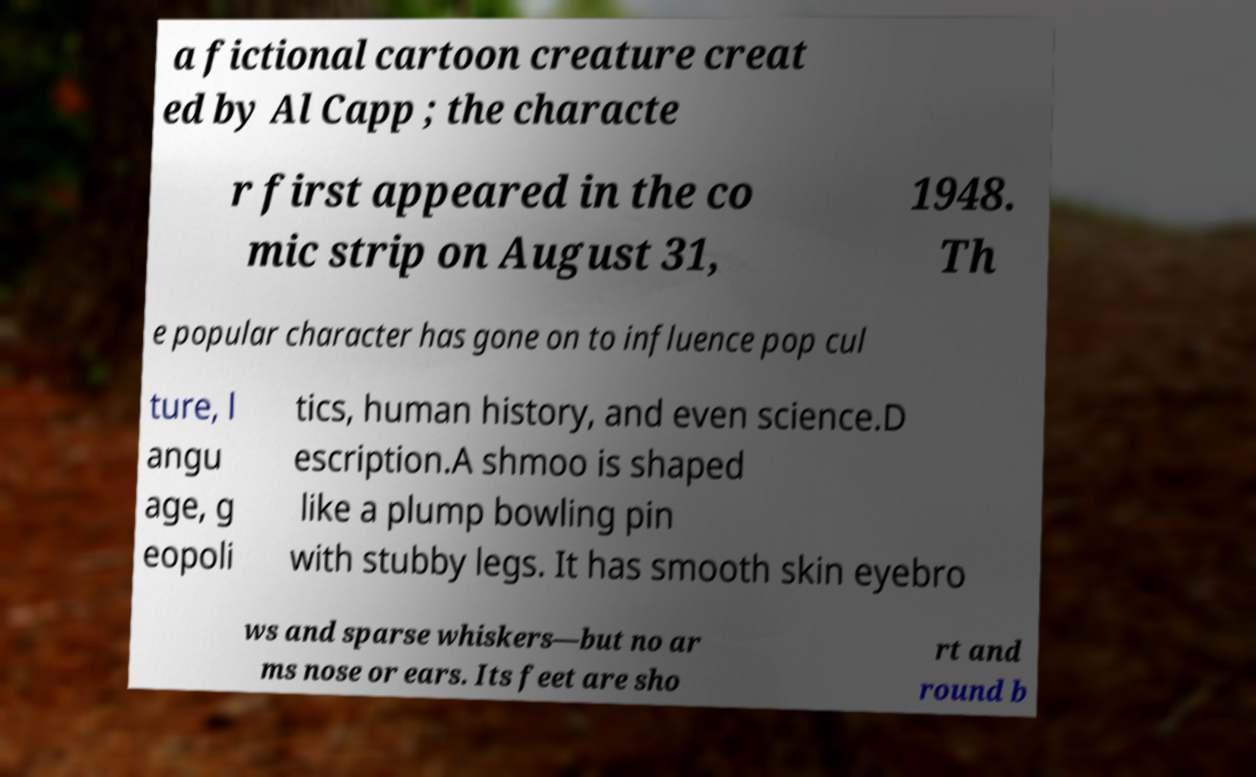For documentation purposes, I need the text within this image transcribed. Could you provide that? a fictional cartoon creature creat ed by Al Capp ; the characte r first appeared in the co mic strip on August 31, 1948. Th e popular character has gone on to influence pop cul ture, l angu age, g eopoli tics, human history, and even science.D escription.A shmoo is shaped like a plump bowling pin with stubby legs. It has smooth skin eyebro ws and sparse whiskers—but no ar ms nose or ears. Its feet are sho rt and round b 